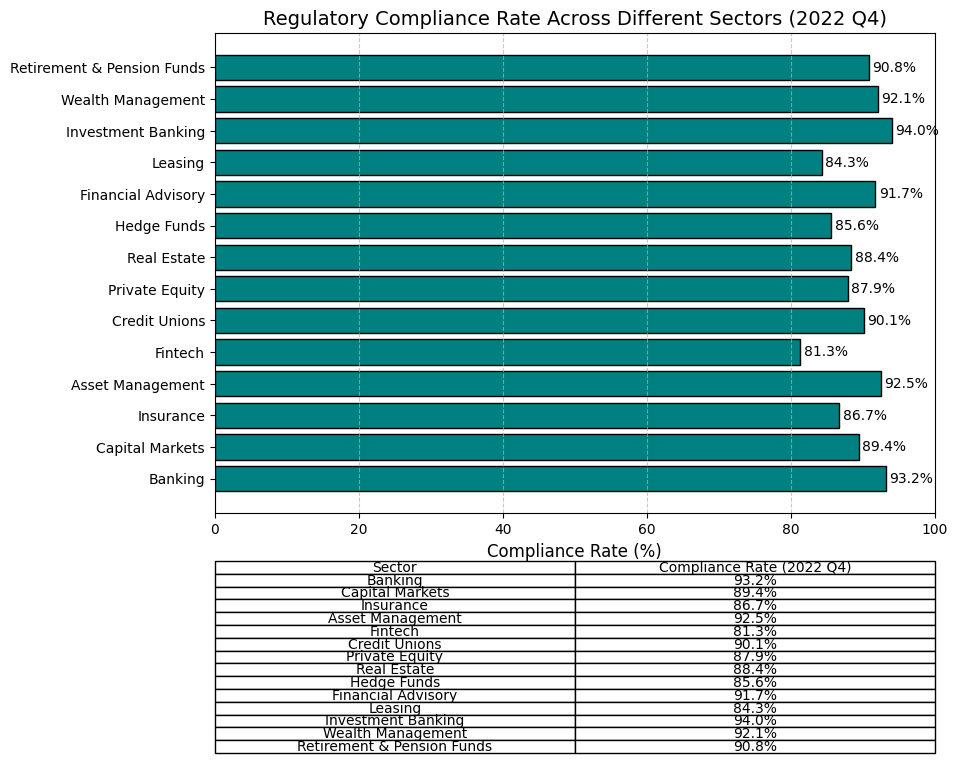Which sector has the highest regulatory compliance rate? The sector with the highest bar visually or the highest percentage in the table is the one with the highest compliance rate.
Answer: Investment Banking What is the difference in compliance rates between the Fintech and Banking sectors? Subtract the compliance rate of Fintech (81.3%) from the compliance rate of Banking (93.2%). 93.2% - 81.3% = 11.9%
Answer: 11.9% Which sectors have a compliance rate between 85% and 90%? Find the sectors where the bar length indicates a compliance rate between 85% and 90%. These sectors are Capital Markets (89.4%), Credit Unions (90.1%), Private Equity (87.9%), Real Estate (88.4%), Hedge Funds (85.6%), Leasing (84.3%).
Answer: Capital Markets, Private Equity, Real Estate, Hedge Funds, Leasing What is the average compliance rate across all sectors? Sum all compliance rates and divide by the number of sectors. (93.2 + 89.4 + 86.7 + 92.5 + 81.3 + 90.1 + 87.9 + 88.4 + 85.6 + 91.7 + 84.3 + 94.0 + 92.1 + 90.8) / 14 = 89.7%
Answer: 89.7% Is the compliance rate for Financial Advisory higher than that of Real Estate? Compare the compliance rate of Financial Advisory (91.7%) with that of Real Estate (88.4%). 91.7% is greater than 88.4%.
Answer: Yes By how much does the compliance rate of Wealth Management exceed that of Hedge Funds? Subtract the compliance rate of Hedge Funds (85.6%) from that of Wealth Management (92.1%). 92.1% - 85.6% = 6.5%
Answer: 6.5% What is the compliance rate range (difference between the highest and lowest rates) across all sectors? Subtract the lowest compliance rate (Fintech 81.3%) from the highest compliance rate (Investment Banking 94.0%). 94.0% - 81.3% = 12.7%
Answer: 12.7% Which sector has the compliance rate closest to 90%? Find the sector with the compliance rate that has the smallest difference from 90%. Credit Unions (90.1%) has a 0.1% difference from 90%.
Answer: Credit Unions How many sectors have a compliance rate greater than 90%? Count the sectors where the compliance rate exceeds 90%. There are 7 such sectors: Banking, Asset Management, Credit Unions, Financial Advisory, Investment Banking, Wealth Management, Retirement & Pension Funds.
Answer: 7 